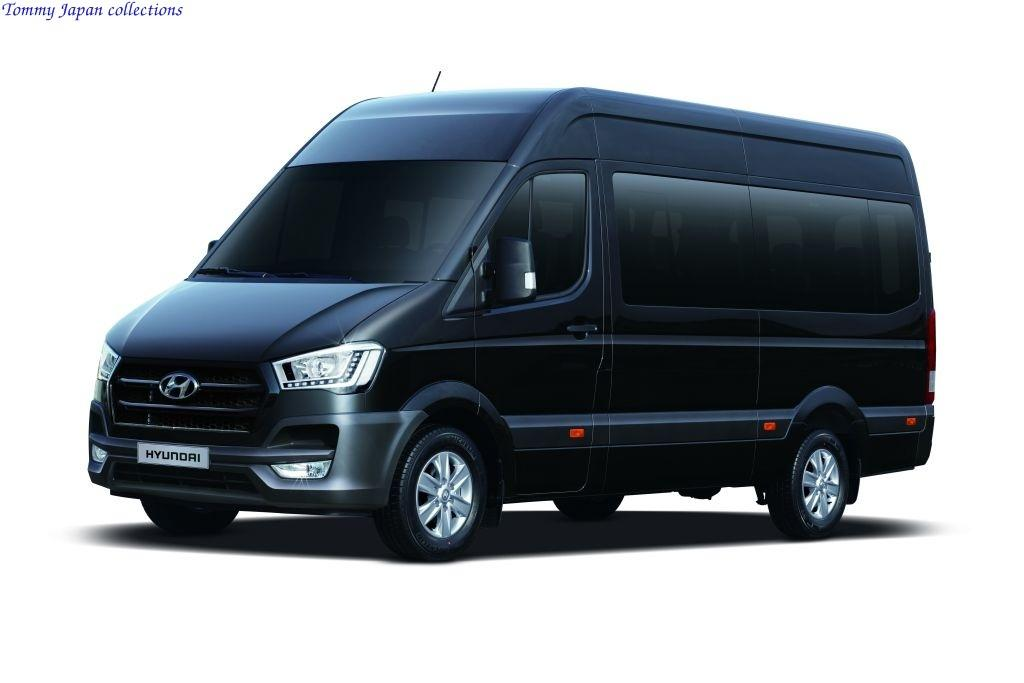<image>
Relay a brief, clear account of the picture shown. A black HYUNDAI van is on display against a white backdrop 